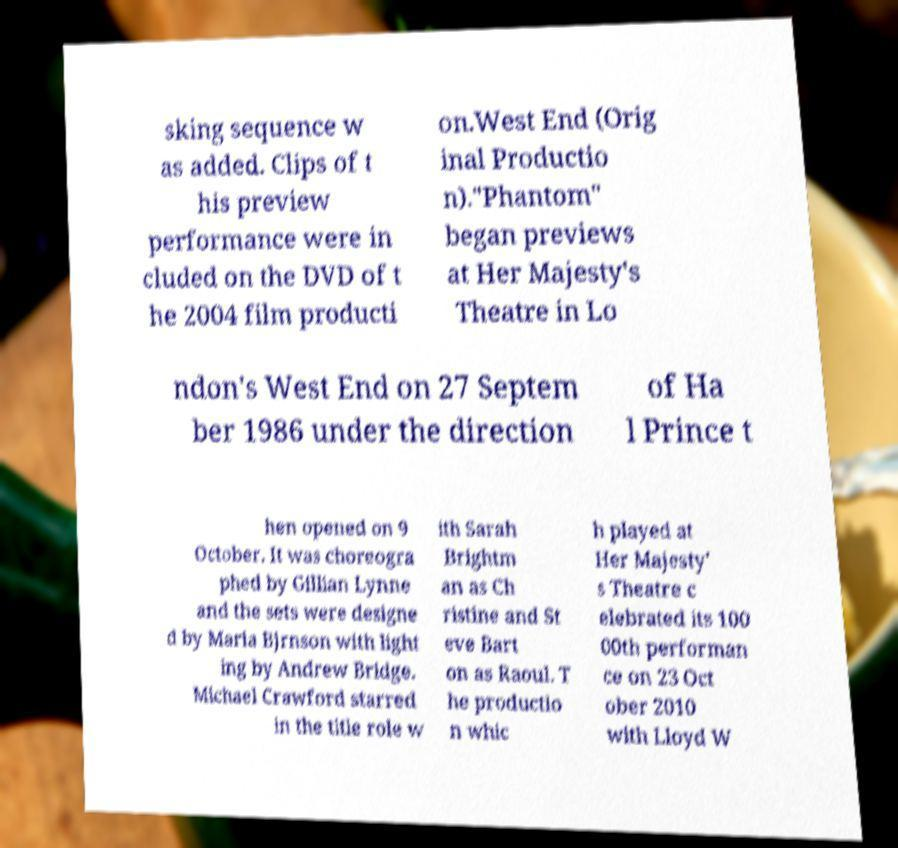Please read and relay the text visible in this image. What does it say? sking sequence w as added. Clips of t his preview performance were in cluded on the DVD of t he 2004 film producti on.West End (Orig inal Productio n)."Phantom" began previews at Her Majesty's Theatre in Lo ndon's West End on 27 Septem ber 1986 under the direction of Ha l Prince t hen opened on 9 October. It was choreogra phed by Gillian Lynne and the sets were designe d by Maria Bjrnson with light ing by Andrew Bridge. Michael Crawford starred in the title role w ith Sarah Brightm an as Ch ristine and St eve Bart on as Raoul. T he productio n whic h played at Her Majesty' s Theatre c elebrated its 100 00th performan ce on 23 Oct ober 2010 with Lloyd W 